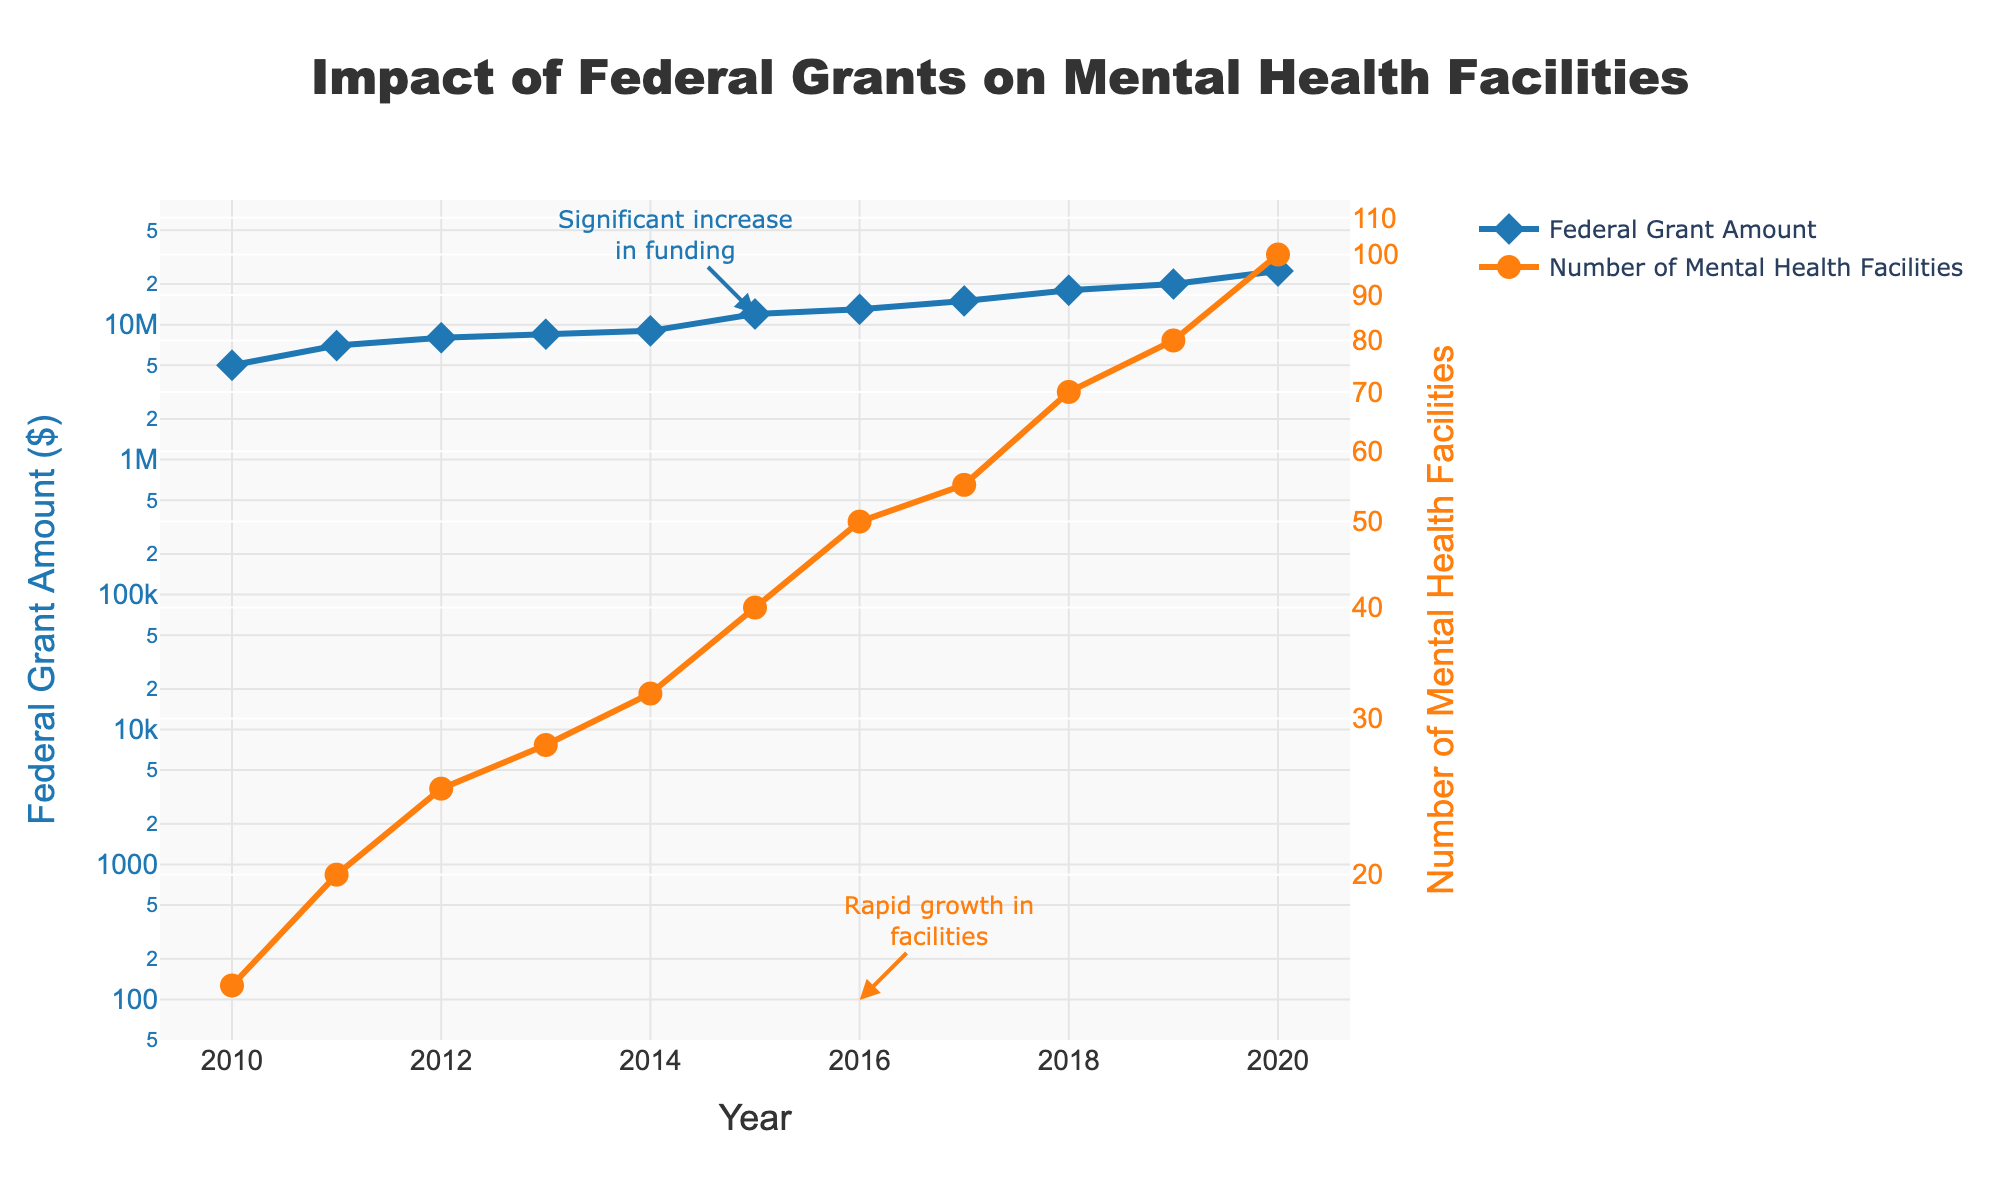How many data points are there for each trace? There are two traces: Federal Grant Amount and Number of Mental Health Facilities. Each trace has a data point for each year from 2010 to 2020, giving 11 data points each.
Answer: 11 What is the title of the figure? The title is displayed at the top of the figure.
Answer: Impact of Federal Grants on Mental Health Facilities Which trace shows a larger increase from 2010 to 2020? Both traces show increases, but the Number of Mental Health Facilities shows a larger proportional increase over the years.
Answer: Number of Mental Health Facilities In which year did the Federal Grant Amount reach $25,000,000? Refer to the Federal Grant Amount trace, look for the year where the grant amount hits $25,000,000.
Answer: 2020 When did the Number of Mental Health Facilities first reach 50? Look at the plot for the Number of Mental Health Facilities, identify the year when it first reached 50.
Answer: 2016 How does the rate of increase in Federal Grant Amount compare with the rate of increase in Mental Health Facilities after 2015? From 2015, both Federal Grant Amount and Number of Mental Health Facilities increase, but the Number of Mental Health Facilities shows a more rapid increase.
Answer: The Number of Mental Health Facilities has a more rapid increase What is the Federal Grant Amount in 2018? Refer to the y-axis for the Federal Grant Amount and find the value corresponding to 2018.
Answer: $18,000,000 By how much did the Number of Mental Health Facilities increase between 2013 and 2018? Subtract the number of facilities in 2013 from the number in 2018: 70 - 28.
Answer: 42 What notable event is indicated by annotations in 2015? An annotation in 2015 highlights a significant increase in Federal Grant Amount.
Answer: Significant increase in funding In which year did the most rapid growth in facilities occur and what annotation indicates this? Refer to the annotations; 2016 has an annotation indicating rapid growth in the number of facilities.
Answer: 2016 